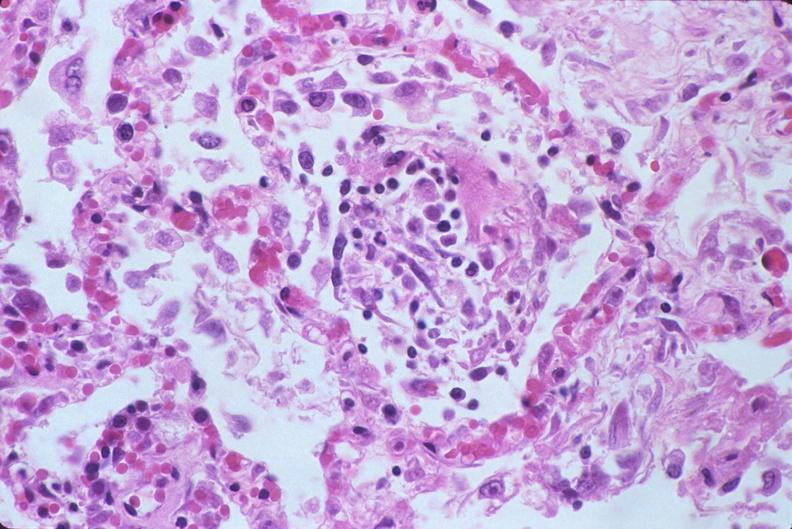s history present?
Answer the question using a single word or phrase. No 